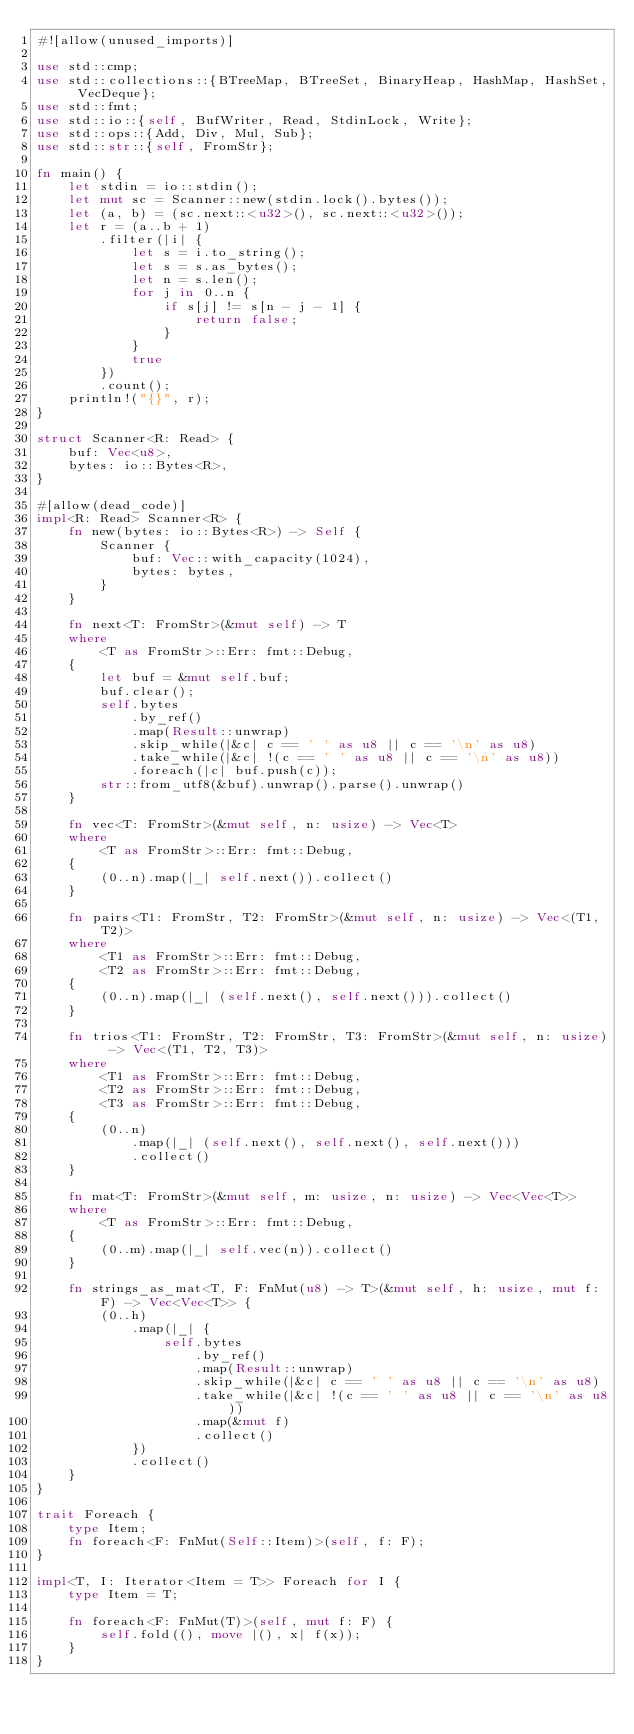Convert code to text. <code><loc_0><loc_0><loc_500><loc_500><_Rust_>#![allow(unused_imports)]

use std::cmp;
use std::collections::{BTreeMap, BTreeSet, BinaryHeap, HashMap, HashSet, VecDeque};
use std::fmt;
use std::io::{self, BufWriter, Read, StdinLock, Write};
use std::ops::{Add, Div, Mul, Sub};
use std::str::{self, FromStr};

fn main() {
    let stdin = io::stdin();
    let mut sc = Scanner::new(stdin.lock().bytes());
    let (a, b) = (sc.next::<u32>(), sc.next::<u32>());
    let r = (a..b + 1)
        .filter(|i| {
            let s = i.to_string();
            let s = s.as_bytes();
            let n = s.len();
            for j in 0..n {
                if s[j] != s[n - j - 1] {
                    return false;
                }
            }
            true
        })
        .count();
    println!("{}", r);
}

struct Scanner<R: Read> {
    buf: Vec<u8>,
    bytes: io::Bytes<R>,
}

#[allow(dead_code)]
impl<R: Read> Scanner<R> {
    fn new(bytes: io::Bytes<R>) -> Self {
        Scanner {
            buf: Vec::with_capacity(1024),
            bytes: bytes,
        }
    }

    fn next<T: FromStr>(&mut self) -> T
    where
        <T as FromStr>::Err: fmt::Debug,
    {
        let buf = &mut self.buf;
        buf.clear();
        self.bytes
            .by_ref()
            .map(Result::unwrap)
            .skip_while(|&c| c == ' ' as u8 || c == '\n' as u8)
            .take_while(|&c| !(c == ' ' as u8 || c == '\n' as u8))
            .foreach(|c| buf.push(c));
        str::from_utf8(&buf).unwrap().parse().unwrap()
    }

    fn vec<T: FromStr>(&mut self, n: usize) -> Vec<T>
    where
        <T as FromStr>::Err: fmt::Debug,
    {
        (0..n).map(|_| self.next()).collect()
    }

    fn pairs<T1: FromStr, T2: FromStr>(&mut self, n: usize) -> Vec<(T1, T2)>
    where
        <T1 as FromStr>::Err: fmt::Debug,
        <T2 as FromStr>::Err: fmt::Debug,
    {
        (0..n).map(|_| (self.next(), self.next())).collect()
    }

    fn trios<T1: FromStr, T2: FromStr, T3: FromStr>(&mut self, n: usize) -> Vec<(T1, T2, T3)>
    where
        <T1 as FromStr>::Err: fmt::Debug,
        <T2 as FromStr>::Err: fmt::Debug,
        <T3 as FromStr>::Err: fmt::Debug,
    {
        (0..n)
            .map(|_| (self.next(), self.next(), self.next()))
            .collect()
    }

    fn mat<T: FromStr>(&mut self, m: usize, n: usize) -> Vec<Vec<T>>
    where
        <T as FromStr>::Err: fmt::Debug,
    {
        (0..m).map(|_| self.vec(n)).collect()
    }

    fn strings_as_mat<T, F: FnMut(u8) -> T>(&mut self, h: usize, mut f: F) -> Vec<Vec<T>> {
        (0..h)
            .map(|_| {
                self.bytes
                    .by_ref()
                    .map(Result::unwrap)
                    .skip_while(|&c| c == ' ' as u8 || c == '\n' as u8)
                    .take_while(|&c| !(c == ' ' as u8 || c == '\n' as u8))
                    .map(&mut f)
                    .collect()
            })
            .collect()
    }
}

trait Foreach {
    type Item;
    fn foreach<F: FnMut(Self::Item)>(self, f: F);
}

impl<T, I: Iterator<Item = T>> Foreach for I {
    type Item = T;

    fn foreach<F: FnMut(T)>(self, mut f: F) {
        self.fold((), move |(), x| f(x));
    }
}
</code> 